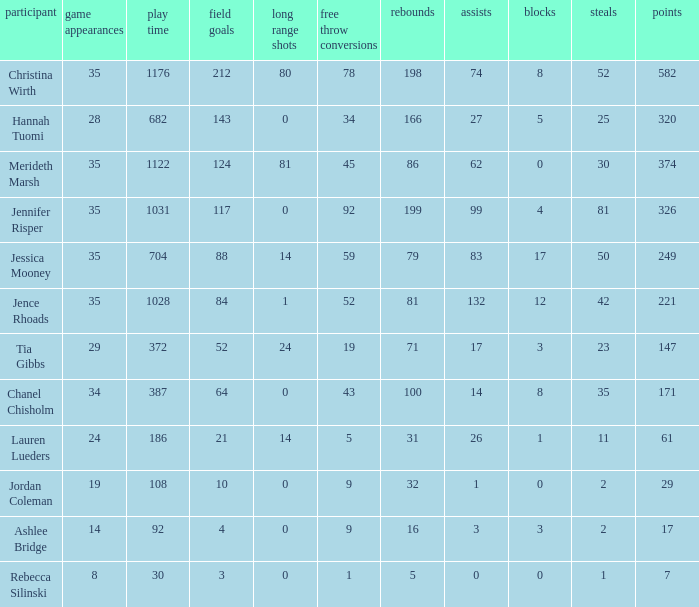What is the lowest number of 3 pointers that occured in games with 52 steals? 80.0. 